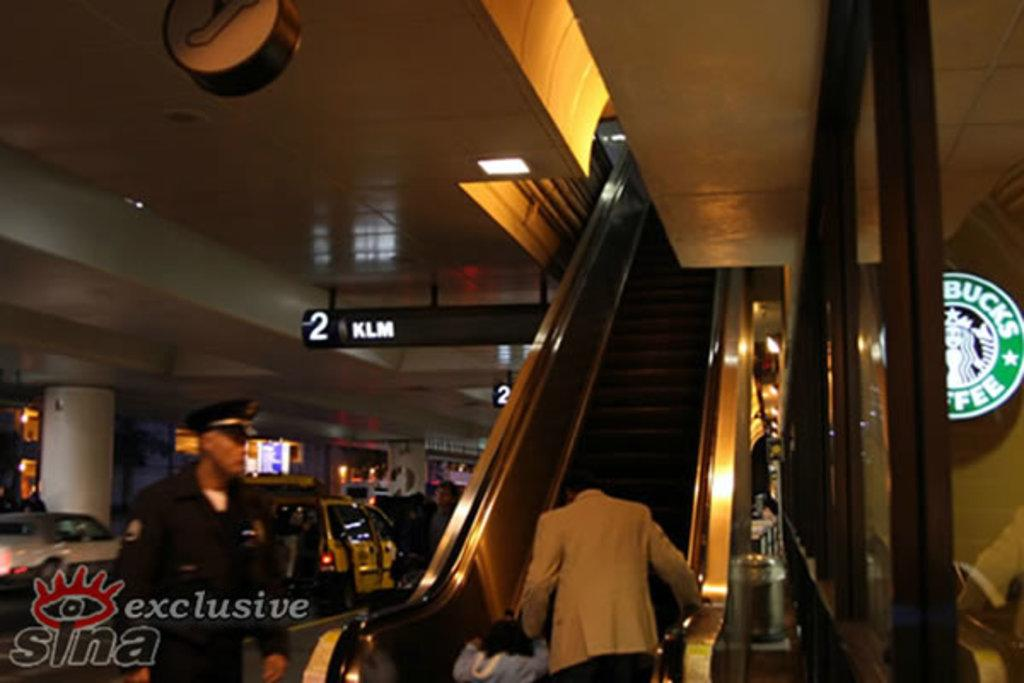<image>
Create a compact narrative representing the image presented. A person going up an escaltor with an ad for Starbucks on the right. 